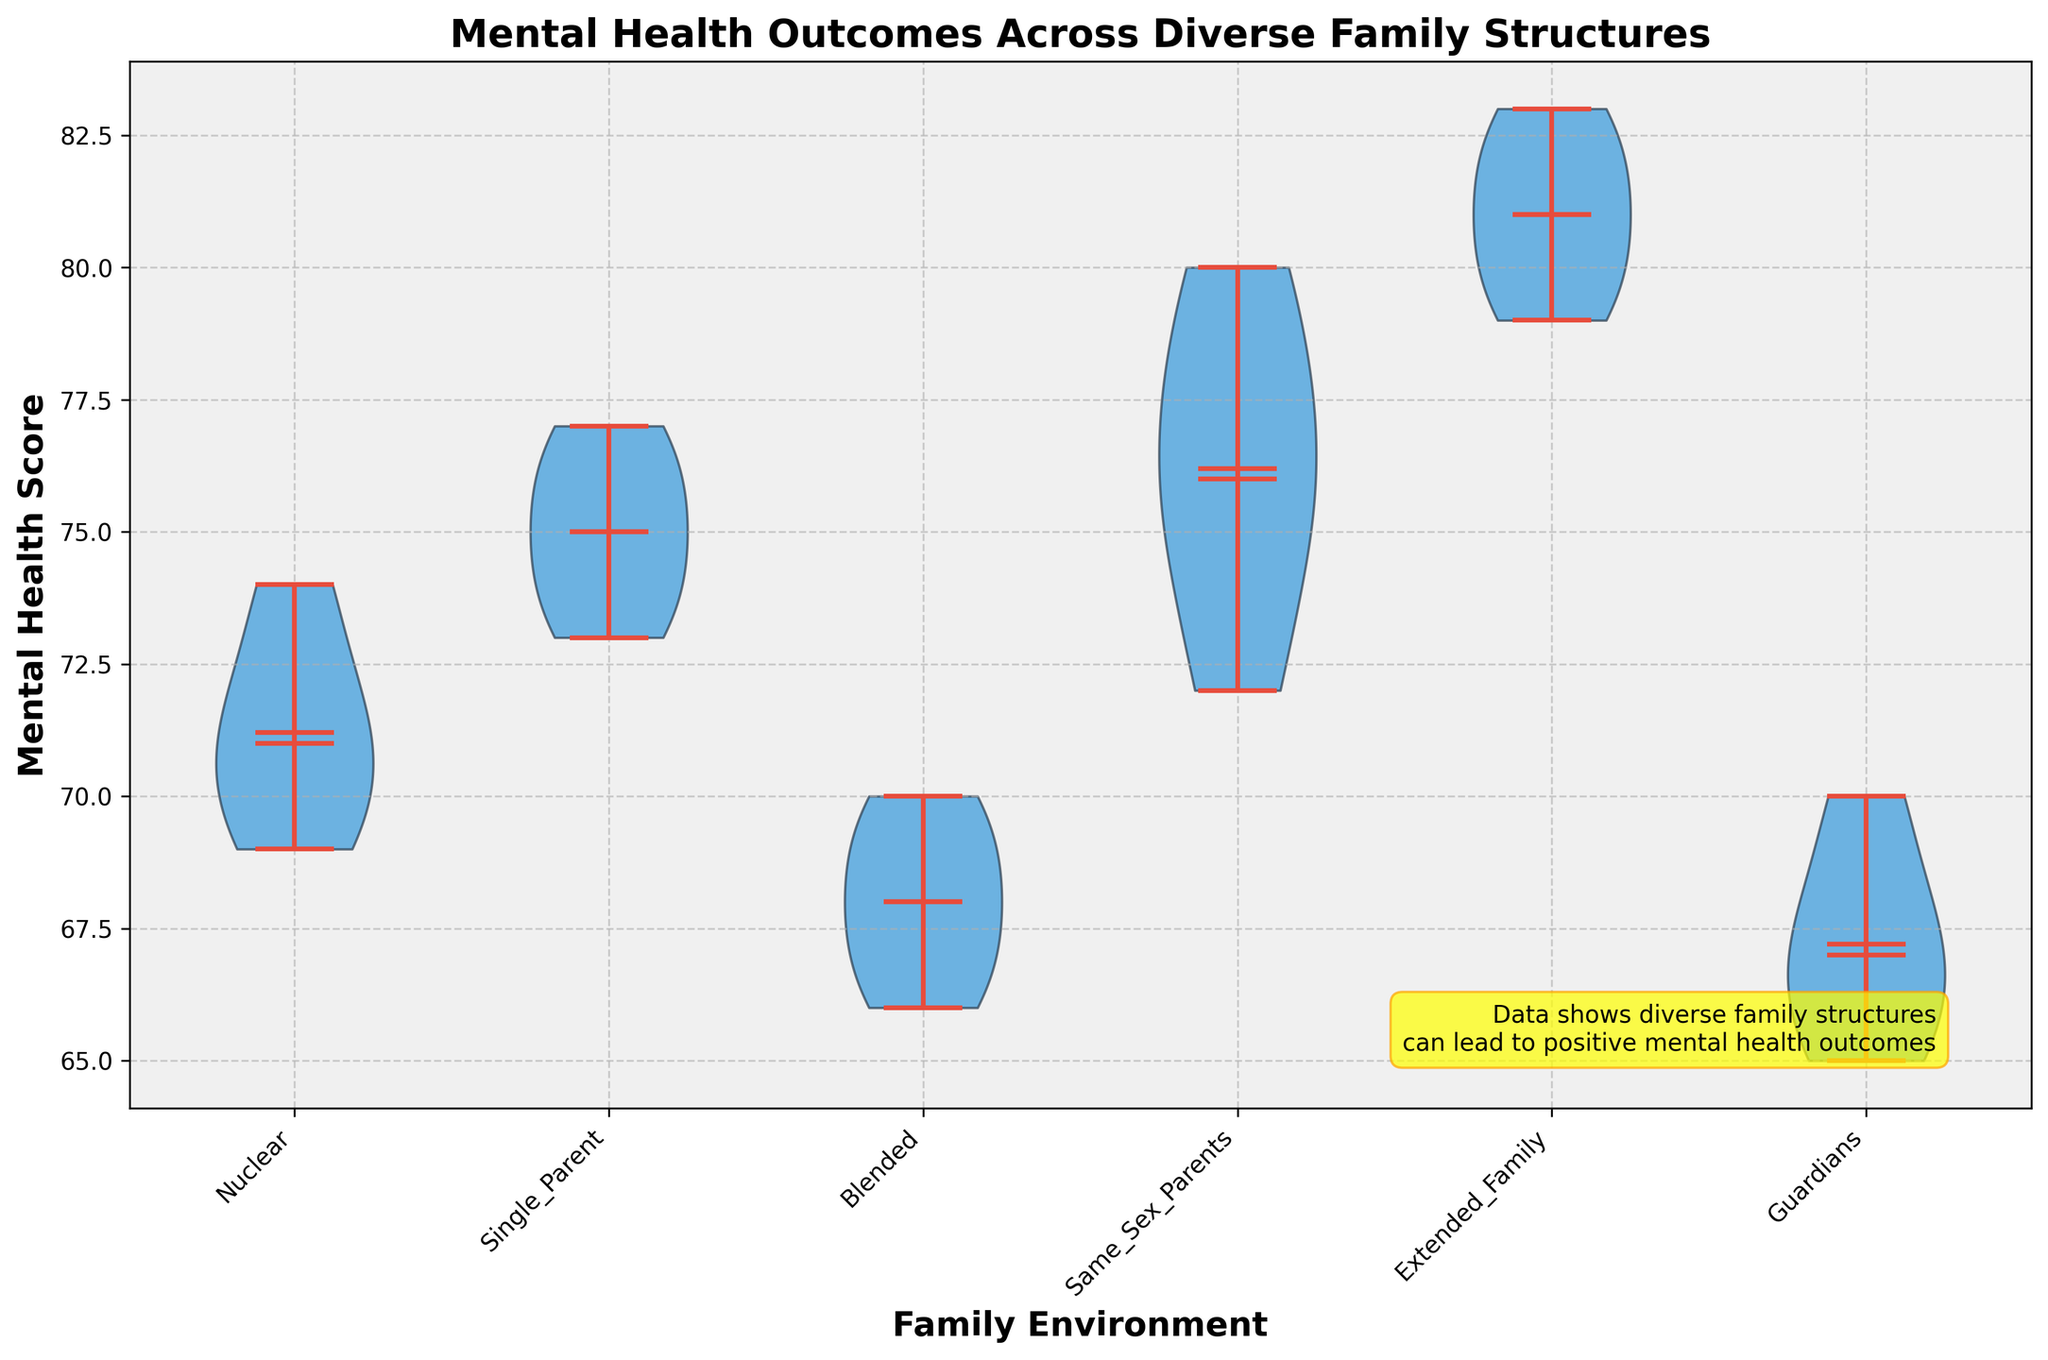What is the title of the violin chart? The title of a figure is usually found at the top and serves to summarize the content being visualized. Here, the title is located at the top and states the focus on mental health outcomes across various family structures.
Answer: Mental Health Outcomes Across Diverse Family Structures How many family environments are represented in the violin chart? The number of family environments can be identified by counting the unique labels on the x-axis representing different family structures. This figure includes "Nuclear", "Single_Parent", "Blended", "Same_Sex_Parents", "Extended_Family", and "Guardians".
Answer: 6 Which family environment has the highest mean mental health score? The mean is indicated by a marker in the middle of each violin plot. By comparing these mean markers, the highest can be identified. The "Same_Sex_Parents" family environment shows the highest mean.
Answer: Same_Sex_Parents What is the median mental health score for adults from nuclear families? The median score is indicated by a horizontal line in the middle of each violin plot. For nuclear families, the median line can be observed at a specific value.
Answer: 76 Which family environment shows the widest range of mental health scores? The range is determined by the distance between the highest and lowest points within a single violin plot. By comparing this distance across all family environments, the one with the widest range can be identified.
Answer: Nuclear How do the mental health outcomes of individuals from single-parent families compare to those from same-sex parent families? To compare, analyze the central location of the means and medians, as well as the spread of the scores in the violin plots. Single-parent families have lower mean and median scores compared to those from same-sex parent families.
Answer: Single-parent families have lower scores What is the color of the violin plots, and why might this choice have been made? The violin plots are shaded with a blue color, while key elements like the means and medians are highlighted with a red color. These choices could be made for visual distinction and clarity.
Answer: Blue (violin plots) and red (means and medians) Which family environment has the most symmetrical distribution of mental health scores? Symmetry in a distribution can be observed by looking at the shape of the violin plots. The one closest to a symmetrical shape on both sides' midlines is "Same_Sex_Parents".
Answer: Same_Sex_Parents How does the mental health score range for individuals raised by guardians compare to those in blended families? By comparing the span of the violin plots, which shows the lowest and highest values, one can determine that blended families tend to have a slightly narrower range than those raised by guardians.
Answer: Guardians have a wider range Which family environment has the tightest clustering of mental health scores around the median? The clustering can be observed by looking at the density of the violin plot around the median line. The family environment that shows a tighter clustered distribution around its median is "Same_Sex_Parents".
Answer: Same_Sex_Parents 